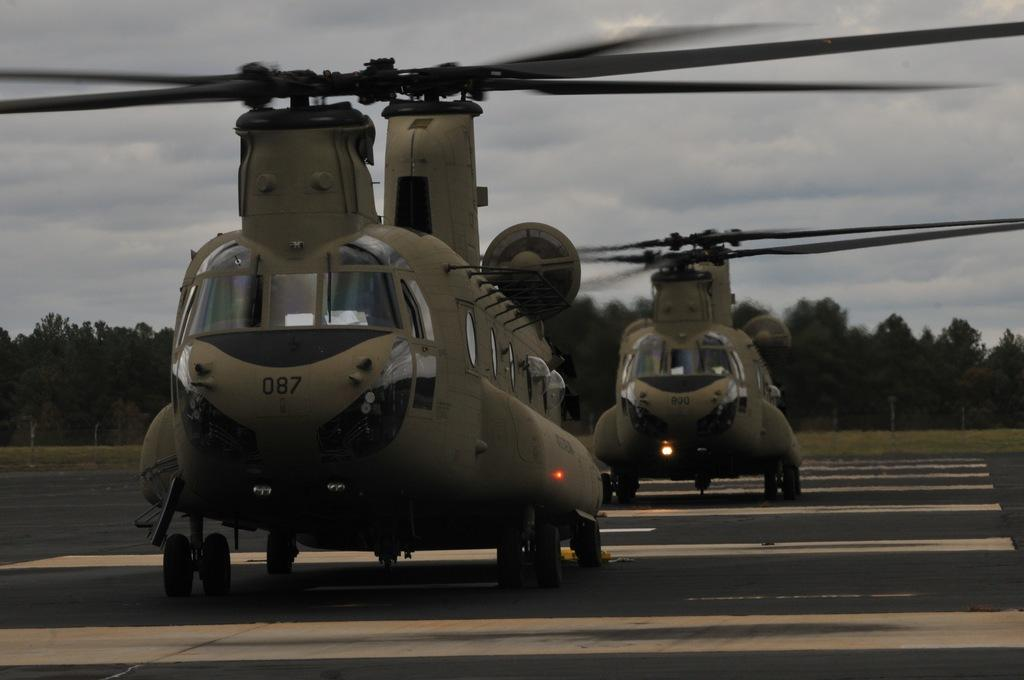What vehicles are present in the image? There are two helicopters in the image. Where are the helicopters located? The helicopters are on the road. What type of landscape can be seen in the image? There is grassland visible in the image, and there are trees in the grassland. What is visible at the top of the image? The sky is visible at the top of the image. What type of baseball equipment can be seen in the image? There is no baseball equipment present in the image. What impulse might cause the helicopters to take off in the image? The image does not provide any information about the reasons for the helicopters being on the road or their potential actions, so it is impossible to determine any impulses. 